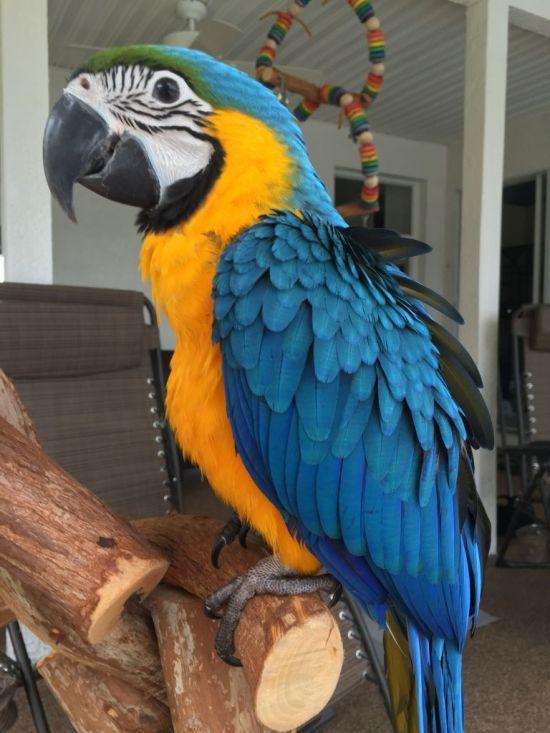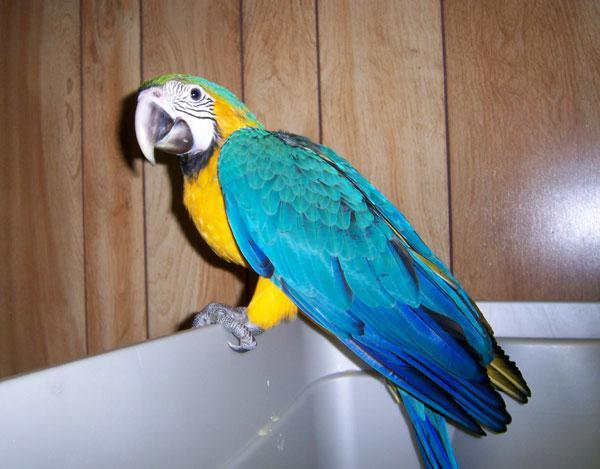The first image is the image on the left, the second image is the image on the right. For the images displayed, is the sentence "there are 3 parrots in the image pair" factually correct? Answer yes or no. No. The first image is the image on the left, the second image is the image on the right. Examine the images to the left and right. Is the description "In one image there is a blue parrot sitting on a perch in the center of the image." accurate? Answer yes or no. Yes. 